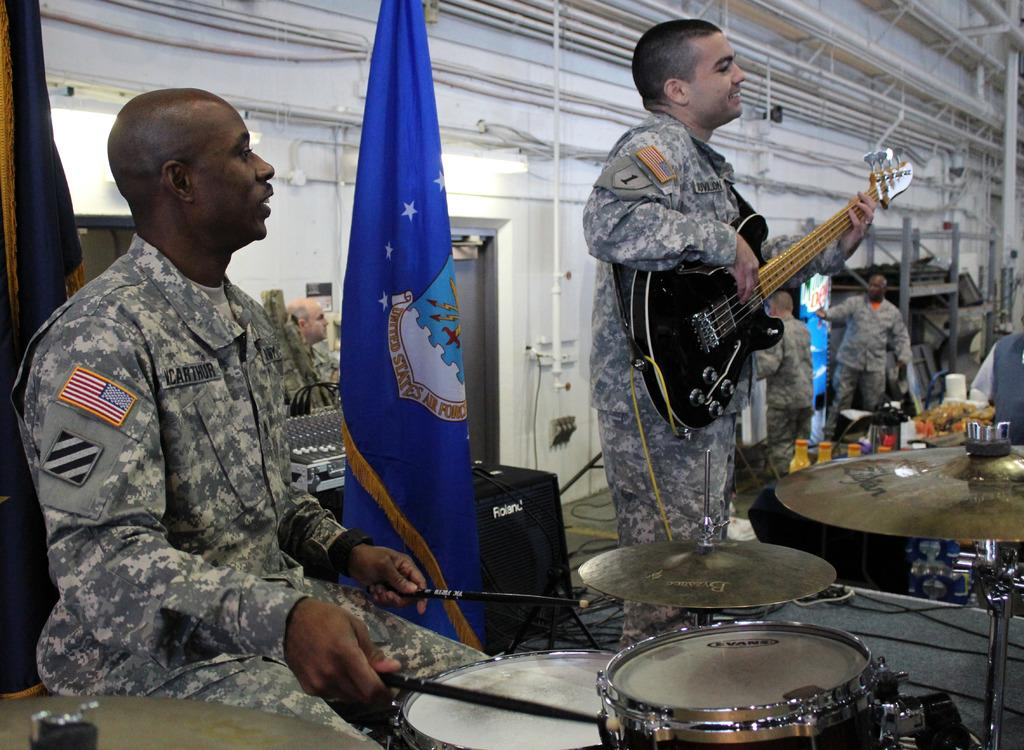What is the main activity being performed by the man in the image? The man is playing a guitar in the image. Can you describe the other person's musical instrument? The other person is playing a musical instrument with sticks. How many people are present in the image? There are people in the image. What object in the image is used for amplifying sound or controlling electronic devices? There is a device in the image. What decorative or symbolic objects can be seen in the image? There are flags in the image. What type of meat is being cooked on the grill in the image? There is no grill or meat present in the image; it features people playing musical instruments and other objects. 